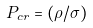Convert formula to latex. <formula><loc_0><loc_0><loc_500><loc_500>P _ { c r } = ( \rho / \sigma )</formula> 